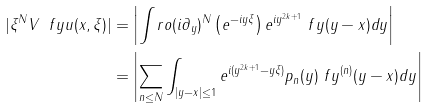<formula> <loc_0><loc_0><loc_500><loc_500>| \xi ^ { N } V _ { \ } f y u ( x , \xi ) | & = \left | \int _ { \ } r o ( i \partial _ { y } ) ^ { N } \left ( e ^ { - i y \xi } \right ) e ^ { i y ^ { 2 k + 1 } } \ f y ( y - x ) d y \right | \\ & = \left | \sum _ { n \leq N } \int _ { | y - x | \leq 1 } e ^ { i ( y ^ { 2 k + 1 } - y \xi ) } p _ { n } ( y ) \ f y ^ { ( n ) } ( y - x ) d y \right | \\</formula> 